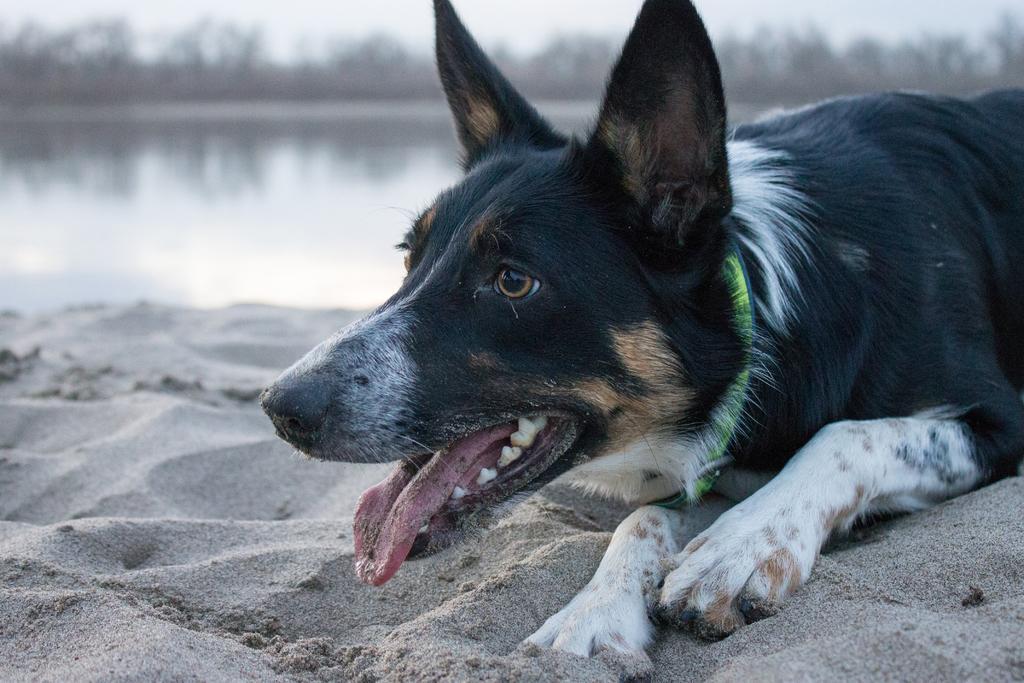How would you summarize this image in a sentence or two? In this picture we can see a dog laying in the front, at the bottom there is sand, in the background we can see water, there is a blurry background. 